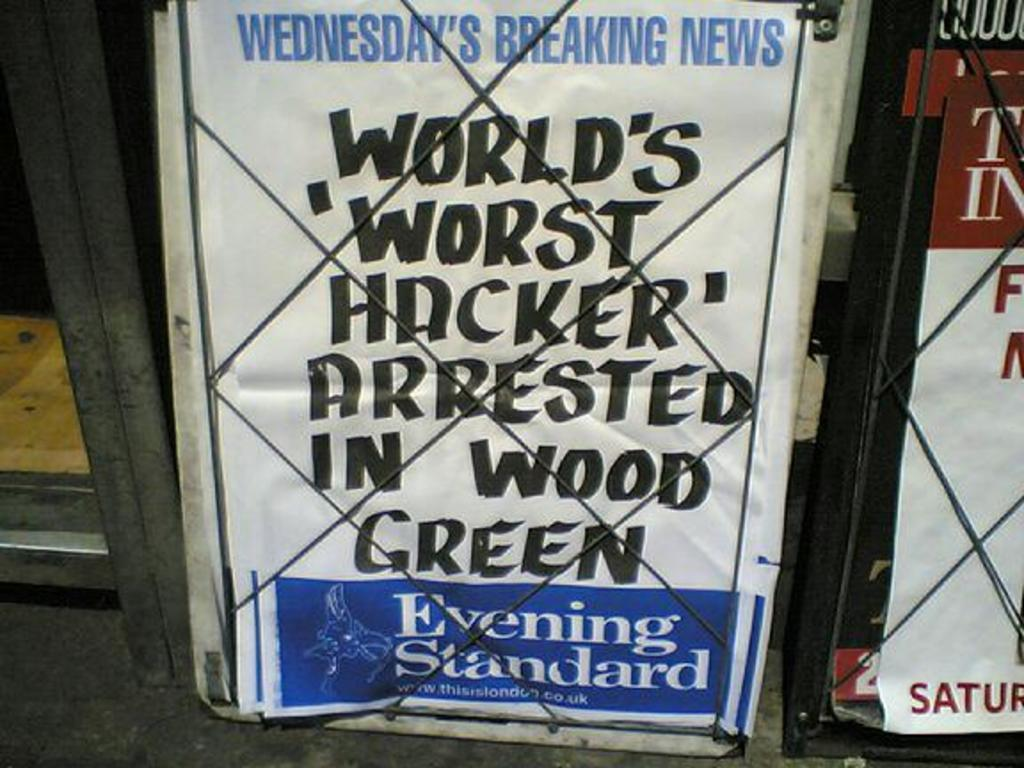<image>
Render a clear and concise summary of the photo. Wednesday's Breaking News can be seen at the top of a newspaper 